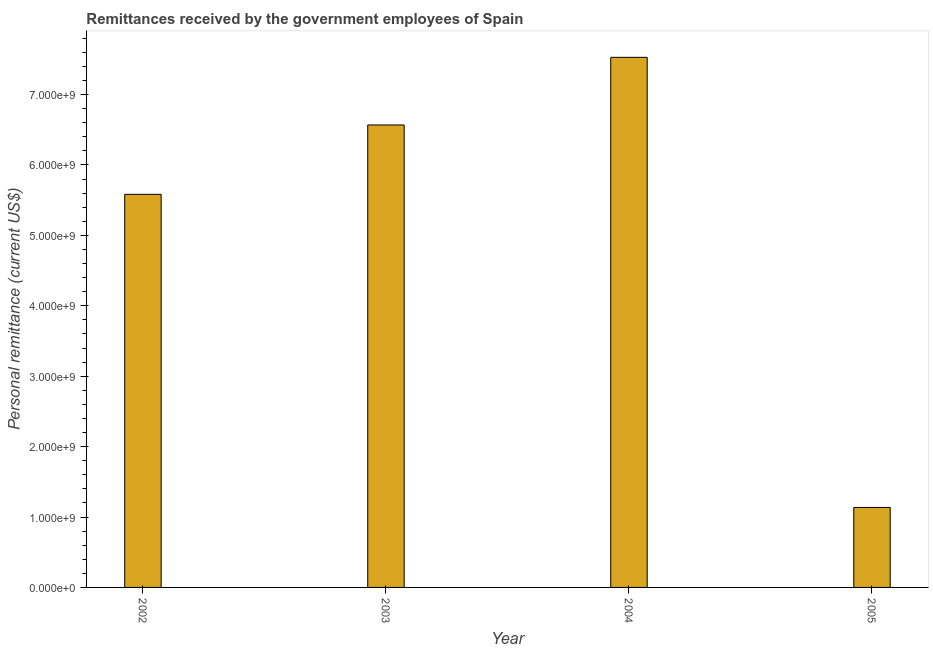Does the graph contain any zero values?
Make the answer very short. No. Does the graph contain grids?
Make the answer very short. No. What is the title of the graph?
Make the answer very short. Remittances received by the government employees of Spain. What is the label or title of the Y-axis?
Offer a terse response. Personal remittance (current US$). What is the personal remittances in 2002?
Your answer should be compact. 5.58e+09. Across all years, what is the maximum personal remittances?
Give a very brief answer. 7.53e+09. Across all years, what is the minimum personal remittances?
Your response must be concise. 1.14e+09. In which year was the personal remittances minimum?
Your answer should be very brief. 2005. What is the sum of the personal remittances?
Offer a terse response. 2.08e+1. What is the difference between the personal remittances in 2002 and 2004?
Give a very brief answer. -1.95e+09. What is the average personal remittances per year?
Provide a short and direct response. 5.20e+09. What is the median personal remittances?
Offer a very short reply. 6.08e+09. What is the ratio of the personal remittances in 2004 to that in 2005?
Your answer should be very brief. 6.63. Is the personal remittances in 2004 less than that in 2005?
Your answer should be compact. No. Is the difference between the personal remittances in 2003 and 2004 greater than the difference between any two years?
Offer a terse response. No. What is the difference between the highest and the second highest personal remittances?
Ensure brevity in your answer.  9.60e+08. Is the sum of the personal remittances in 2003 and 2004 greater than the maximum personal remittances across all years?
Provide a short and direct response. Yes. What is the difference between the highest and the lowest personal remittances?
Your response must be concise. 6.39e+09. How many bars are there?
Offer a very short reply. 4. Are all the bars in the graph horizontal?
Provide a short and direct response. No. How many years are there in the graph?
Provide a succinct answer. 4. What is the difference between two consecutive major ticks on the Y-axis?
Your answer should be compact. 1.00e+09. What is the Personal remittance (current US$) of 2002?
Offer a terse response. 5.58e+09. What is the Personal remittance (current US$) of 2003?
Your answer should be very brief. 6.57e+09. What is the Personal remittance (current US$) of 2004?
Ensure brevity in your answer.  7.53e+09. What is the Personal remittance (current US$) of 2005?
Your answer should be very brief. 1.14e+09. What is the difference between the Personal remittance (current US$) in 2002 and 2003?
Your answer should be compact. -9.85e+08. What is the difference between the Personal remittance (current US$) in 2002 and 2004?
Your response must be concise. -1.95e+09. What is the difference between the Personal remittance (current US$) in 2002 and 2005?
Make the answer very short. 4.45e+09. What is the difference between the Personal remittance (current US$) in 2003 and 2004?
Your answer should be compact. -9.60e+08. What is the difference between the Personal remittance (current US$) in 2003 and 2005?
Your answer should be compact. 5.43e+09. What is the difference between the Personal remittance (current US$) in 2004 and 2005?
Your answer should be very brief. 6.39e+09. What is the ratio of the Personal remittance (current US$) in 2002 to that in 2003?
Provide a succinct answer. 0.85. What is the ratio of the Personal remittance (current US$) in 2002 to that in 2004?
Make the answer very short. 0.74. What is the ratio of the Personal remittance (current US$) in 2002 to that in 2005?
Keep it short and to the point. 4.92. What is the ratio of the Personal remittance (current US$) in 2003 to that in 2004?
Your answer should be very brief. 0.87. What is the ratio of the Personal remittance (current US$) in 2003 to that in 2005?
Ensure brevity in your answer.  5.78. What is the ratio of the Personal remittance (current US$) in 2004 to that in 2005?
Offer a very short reply. 6.63. 